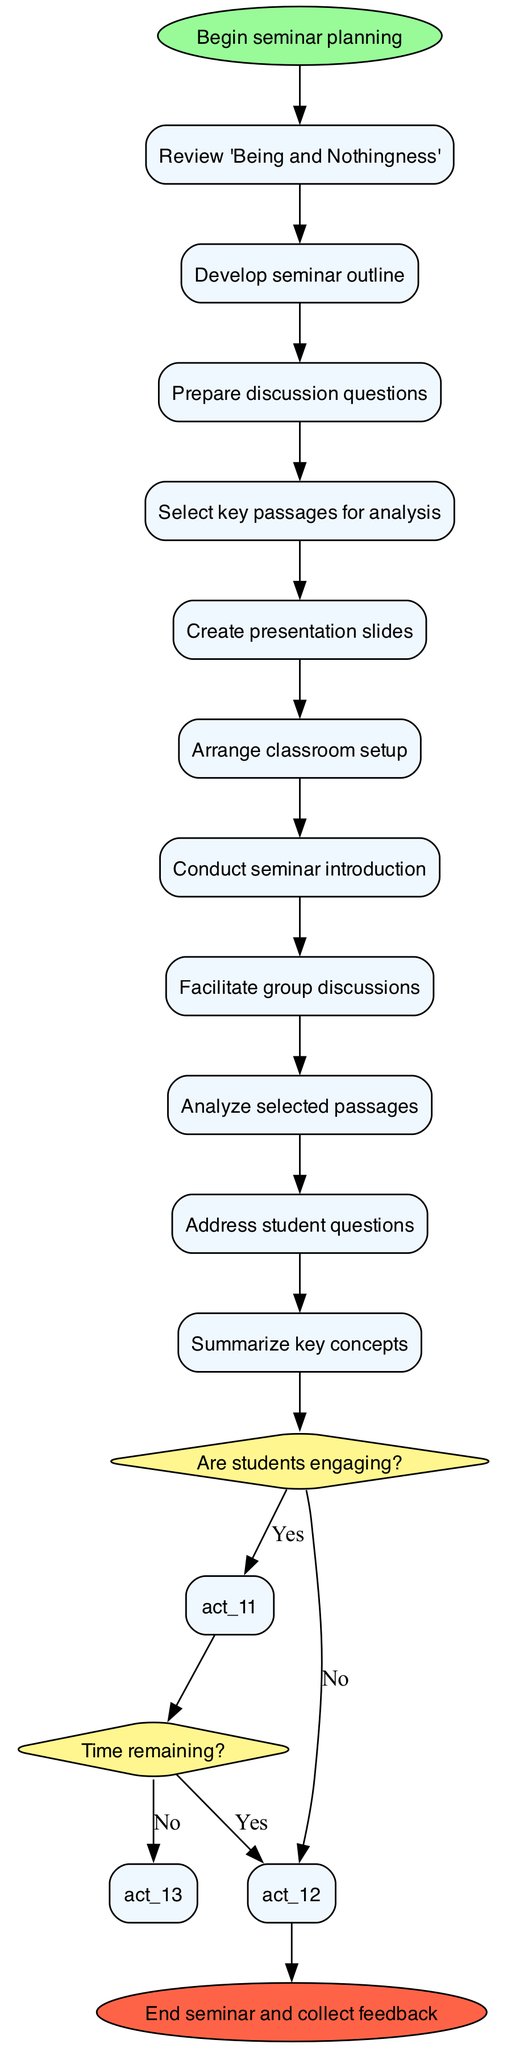What is the first activity in the seminar workflow? The first activity listed in the diagram is the first one that connects from the start node, which is to "Review 'Being and Nothingness'."
Answer: Review 'Being and Nothingness' How many activities are involved in the seminar organization? By counting the activities listed in the diagram, there are a total of 11 activities included in the workflow.
Answer: 11 What decision follows the "Conduct seminar introduction" activity? The decision that follows is about student engagement, asking "Are students engaging?" It directly connects to the last activity before the decision node.
Answer: Are students engaging? What happens if the answer to the decision "Are students engaging?" is no? If the answer is no, the next step in the flow is to "Adjust discussion approach" as indicated in the decision paths stemming from the node.
Answer: Adjust discussion approach What is the final activity before concluding the seminar? The final activity listed before reaching the ending node is "Summarize key concepts," which leads to the conclusion of the seminar and collection of feedback.
Answer: Summarize key concepts How many decision nodes are present in the diagram? The diagram includes 2 decision nodes: the first decision about student engagement and the second about time remaining.
Answer: 2 If there is time remaining after discussing the activities, what is the subsequent action? In the case where there is time remaining, indicated by a "yes" answer on the decision about time, the next action is to "Proceed to next topic."
Answer: Proceed to next topic What is the conclusion activity of the seminar workflow? The diagram indicates that the conclusion activity, which is the final step, is to "End seminar and collect feedback."
Answer: End seminar and collect feedback 